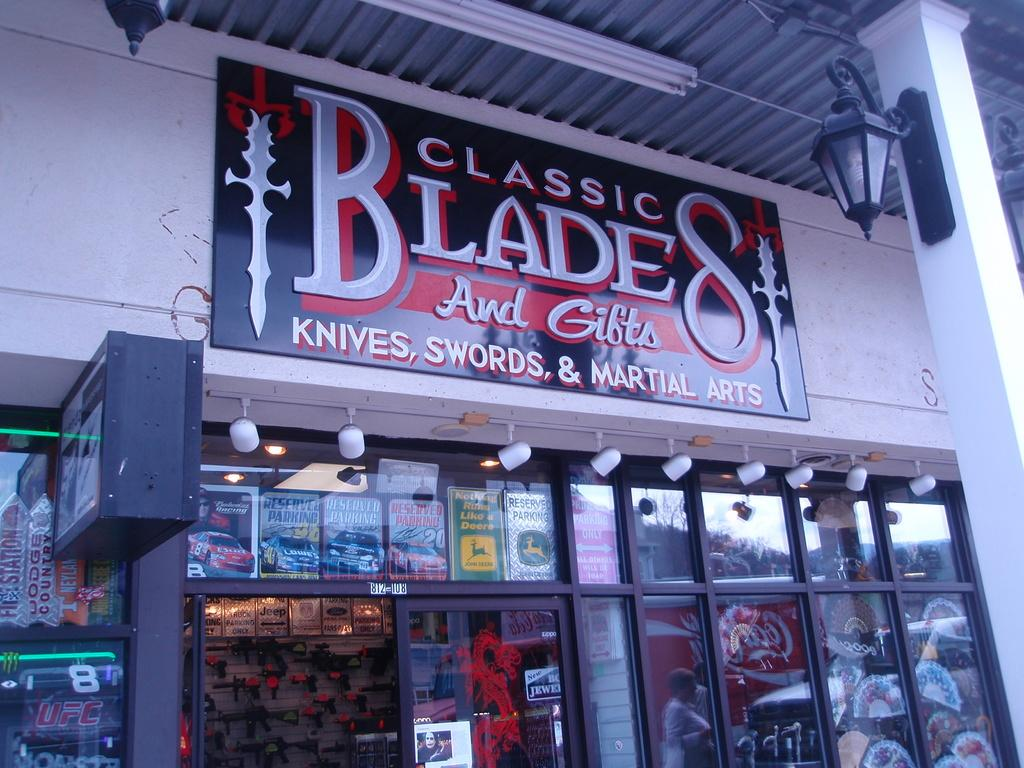<image>
Write a terse but informative summary of the picture. Classic Blades and Gifts has a black, red and silver sign above it's store front. 